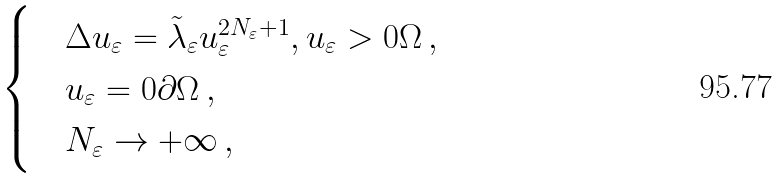<formula> <loc_0><loc_0><loc_500><loc_500>\begin{cases} & \Delta u _ { \varepsilon } = \tilde { \lambda } _ { \varepsilon } u _ { \varepsilon } ^ { 2 N _ { \varepsilon } + 1 } , u _ { \varepsilon } > 0 \Omega \, , \\ & u _ { \varepsilon } = 0 \partial \Omega \, , \\ & N _ { \varepsilon } \to + \infty \, , \end{cases}</formula> 